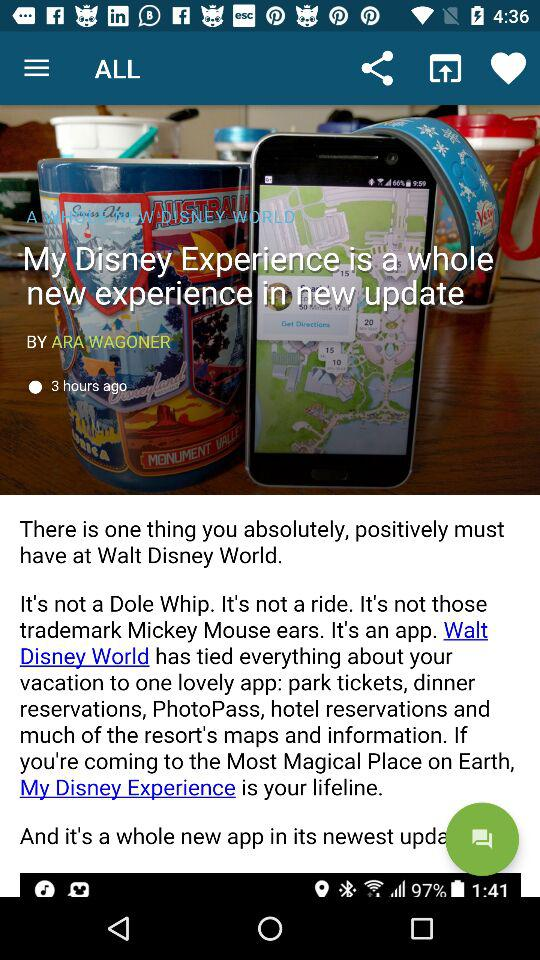What is the time duration of the publication?
When the provided information is insufficient, respond with <no answer>. <no answer> 